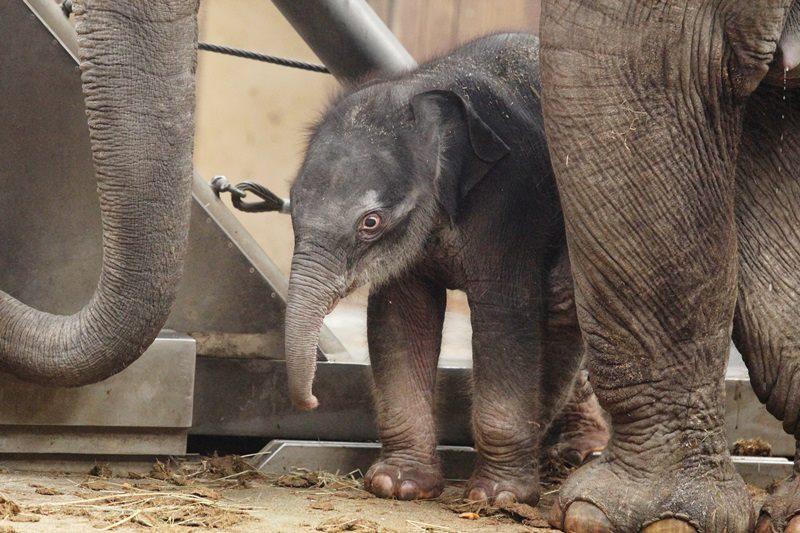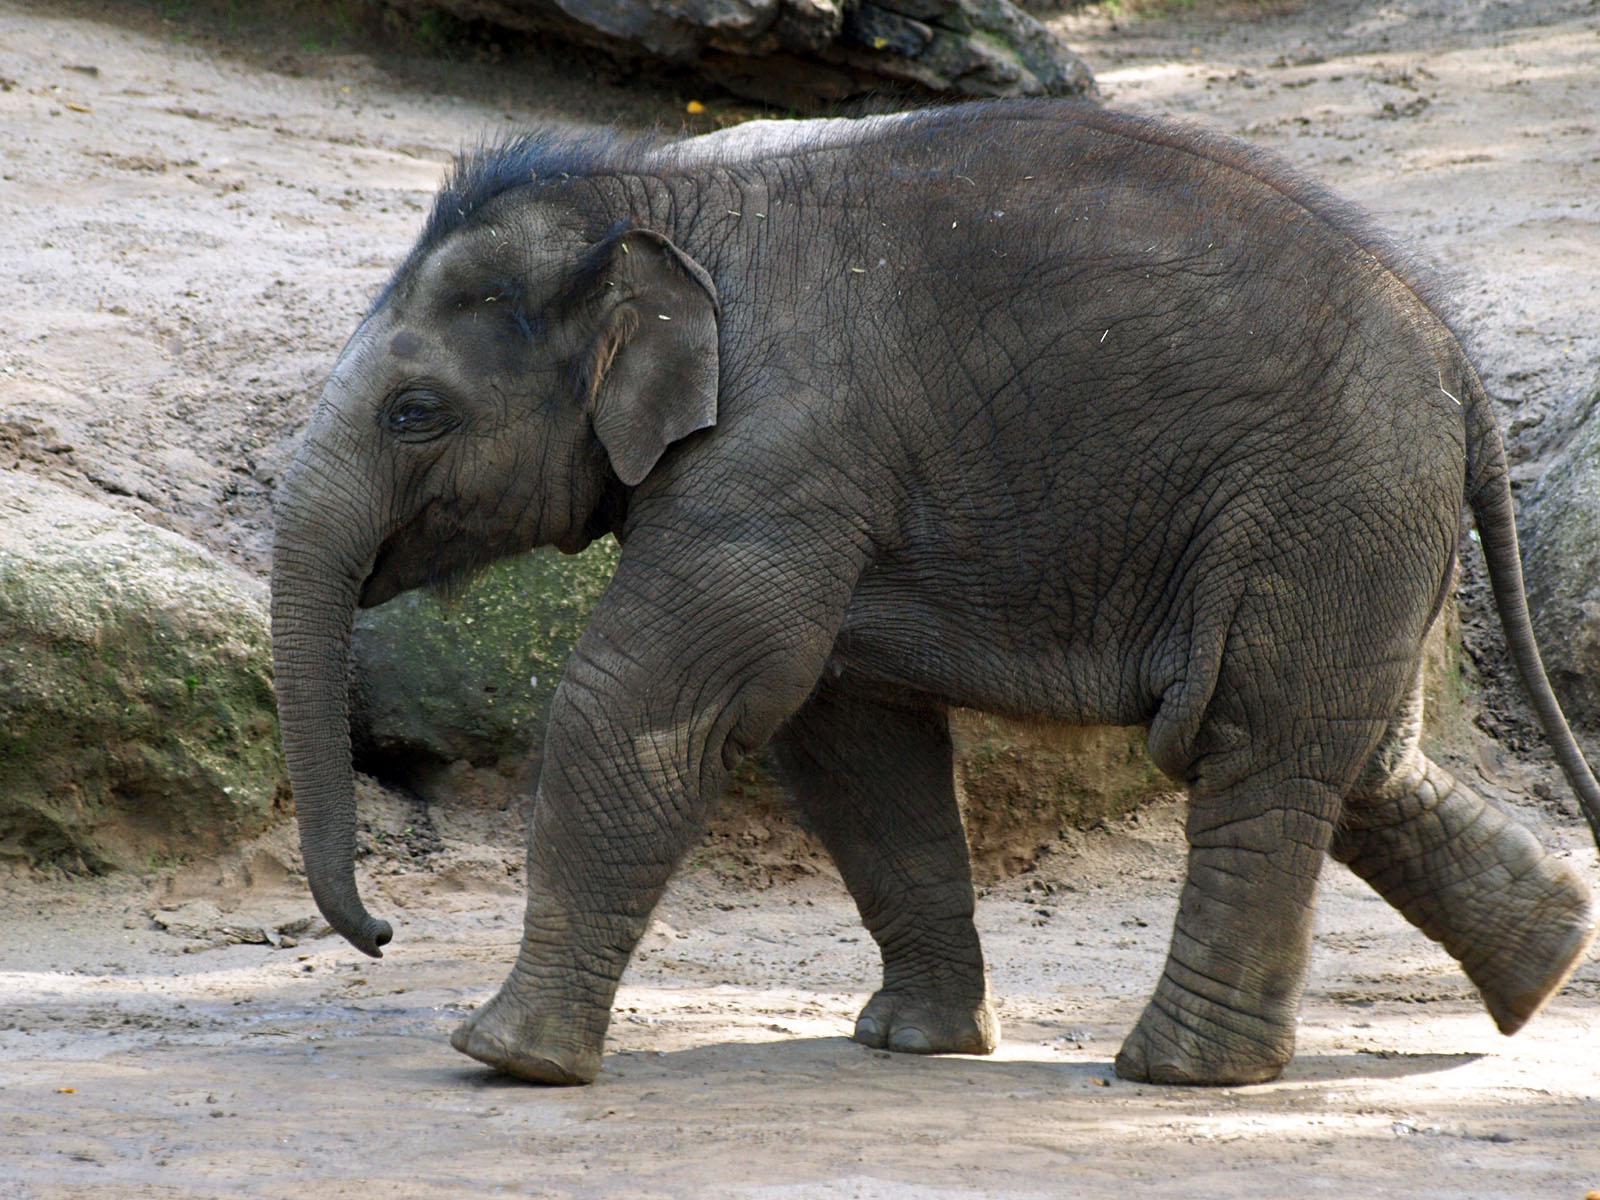The first image is the image on the left, the second image is the image on the right. Examine the images to the left and right. Is the description "there are two elephants in the image on the right" accurate? Answer yes or no. No. The first image is the image on the left, the second image is the image on the right. Assess this claim about the two images: "There is 1 small elephant climbing on something.". Correct or not? Answer yes or no. No. The first image is the image on the left, the second image is the image on the right. Assess this claim about the two images: "One of the images shows only one elephant.". Correct or not? Answer yes or no. Yes. The first image is the image on the left, the second image is the image on the right. Analyze the images presented: Is the assertion "A mother and baby elephant are actively engaged together in a natural setting." valid? Answer yes or no. No. 